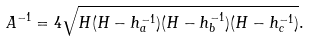Convert formula to latex. <formula><loc_0><loc_0><loc_500><loc_500>A ^ { - 1 } = 4 { \sqrt { H ( H - h _ { a } ^ { - 1 } ) ( H - h _ { b } ^ { - 1 } ) ( H - h _ { c } ^ { - 1 } ) } } .</formula> 